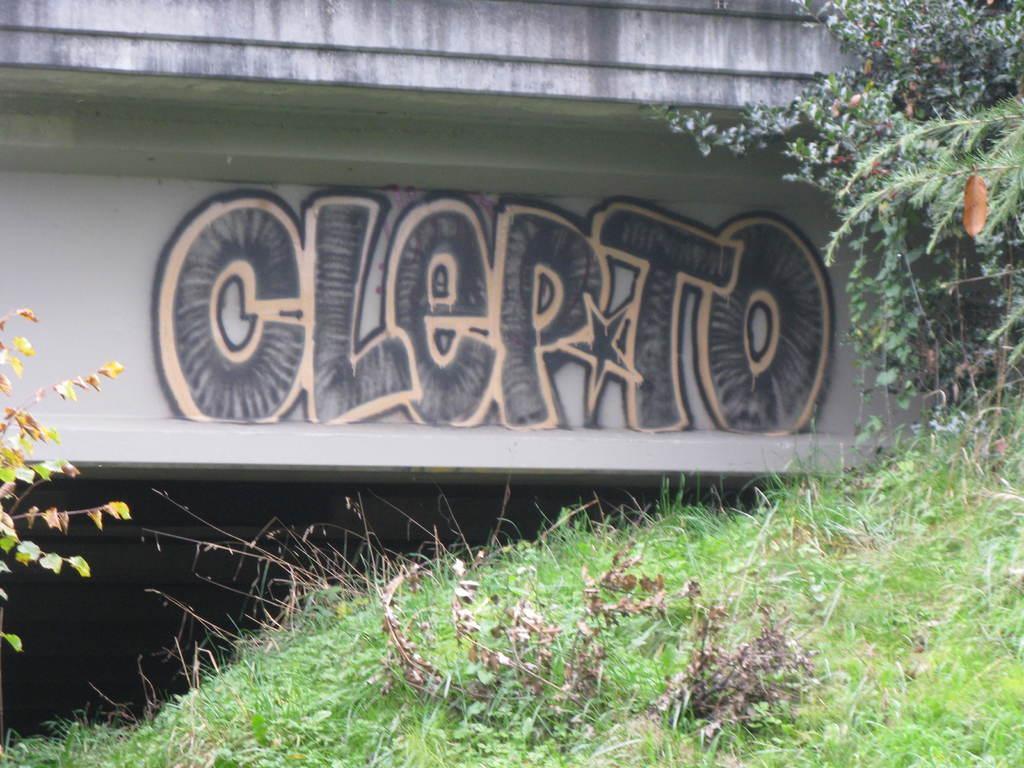How would you summarize this image in a sentence or two? This picture shows a text painting on the wall and we see grass on the ground and few trees. 